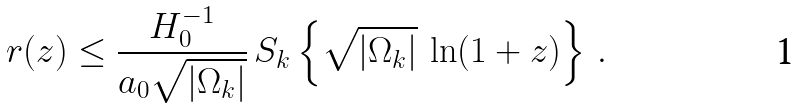<formula> <loc_0><loc_0><loc_500><loc_500>r ( z ) \leq \frac { H _ { 0 } ^ { - 1 } } { a _ { 0 } \sqrt { | \Omega _ { k } | } } \, S _ { k } \left \{ \sqrt { | \Omega _ { k } | } \, \ln ( 1 + z ) \right \} \, .</formula> 